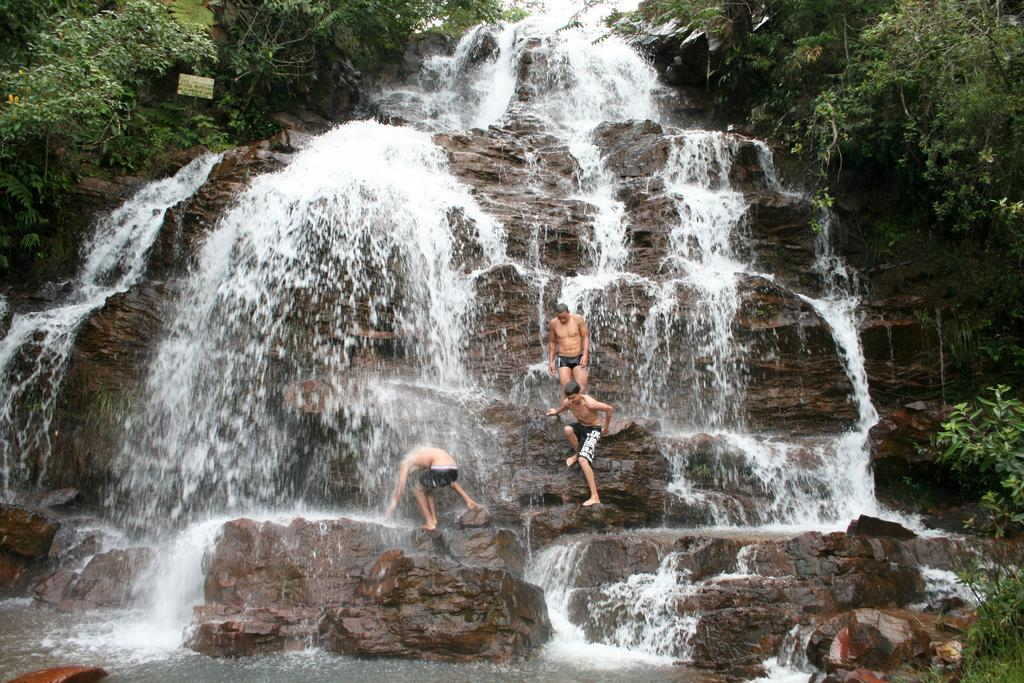What is happening in the image? There is water flowing in the image. What can be seen in the background of the image? There are trees in the image. What are the individuals doing in the image? There are individuals standing on rocks in the image. What type of berry is being used as a language in the image? There is no berry or language present in the image; it features water flowing, trees, and individuals standing on rocks. 